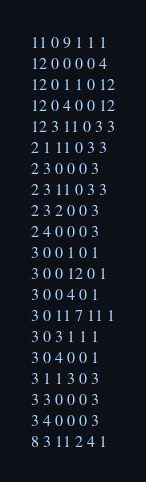<code> <loc_0><loc_0><loc_500><loc_500><_SQL_>11 0 9 1 1 1
12 0 0 0 0 4
12 0 1 1 0 12
12 0 4 0 0 12
12 3 11 0 3 3
2 1 11 0 3 3
2 3 0 0 0 3
2 3 11 0 3 3
2 3 2 0 0 3
2 4 0 0 0 3
3 0 0 1 0 1
3 0 0 12 0 1
3 0 0 4 0 1
3 0 11 7 11 1
3 0 3 1 1 1
3 0 4 0 0 1
3 1 1 3 0 3
3 3 0 0 0 3
3 4 0 0 0 3
8 3 11 2 4 1
</code> 